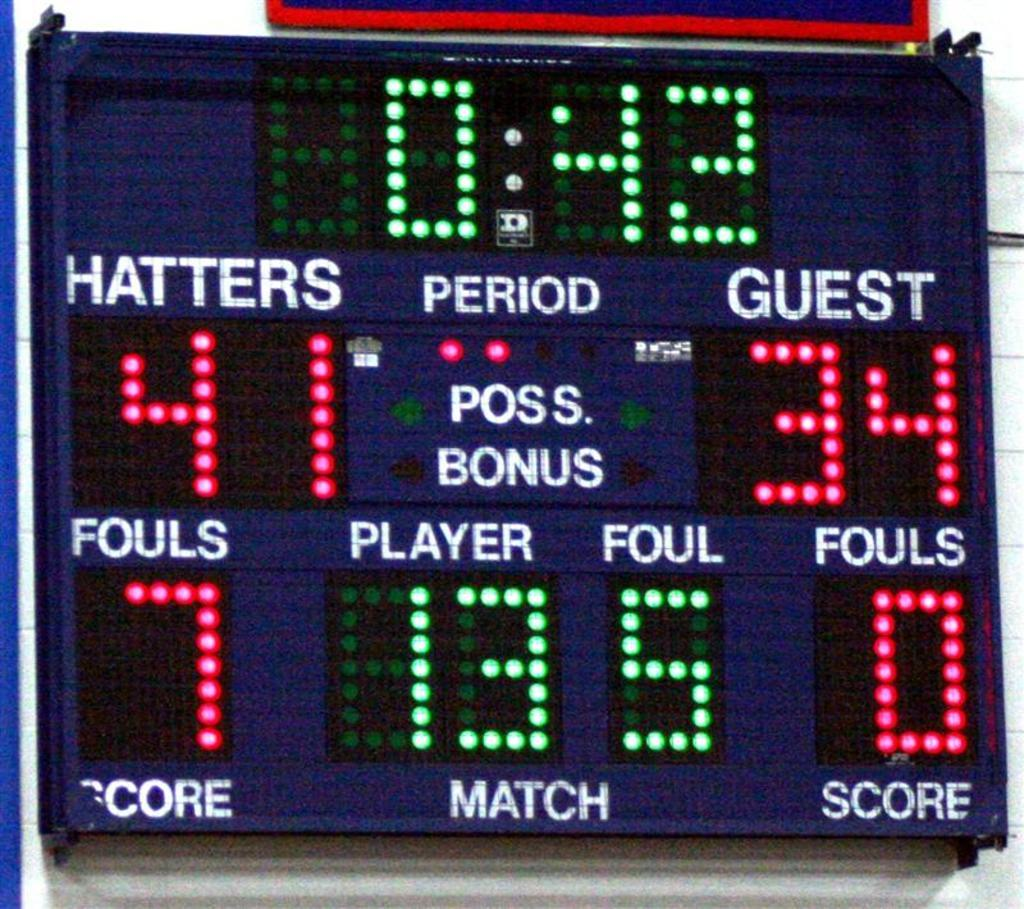<image>
Write a terse but informative summary of the picture. a scoreboard with the score of 41-34 on it 